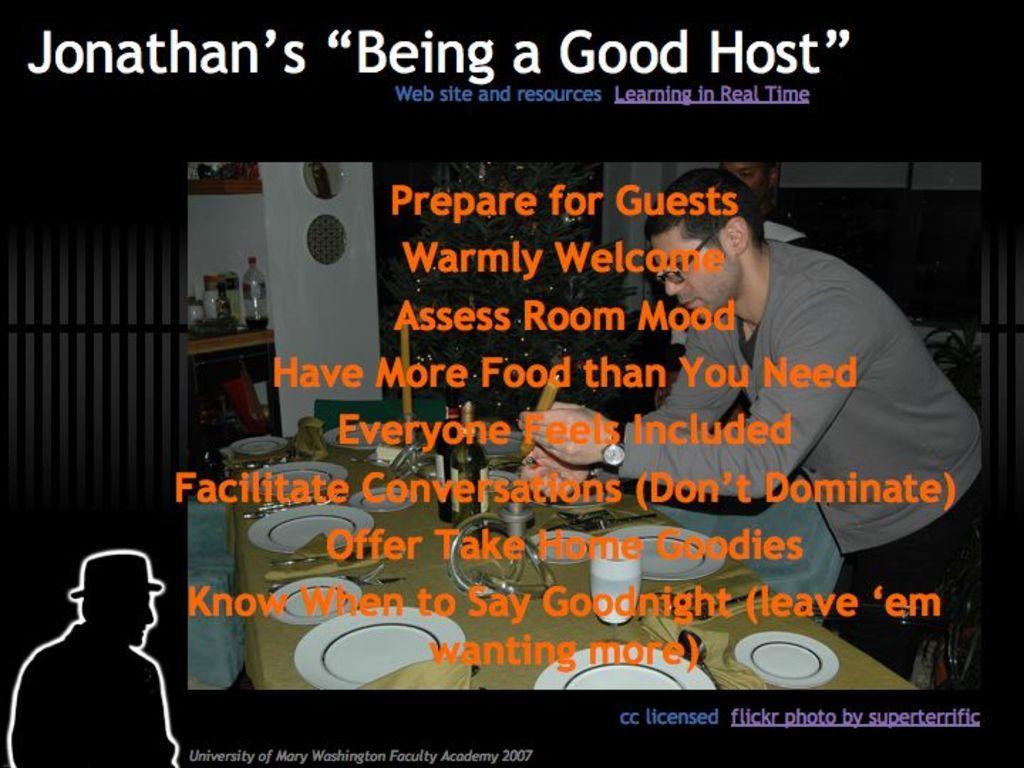How would you summarize this image in a sentence or two? In this image I can see a man is standing in front of a table. On the table I can see plates, glasses and other objects on it. In the background I can see wall, bottles and other objects. I can also see some text on the image. 